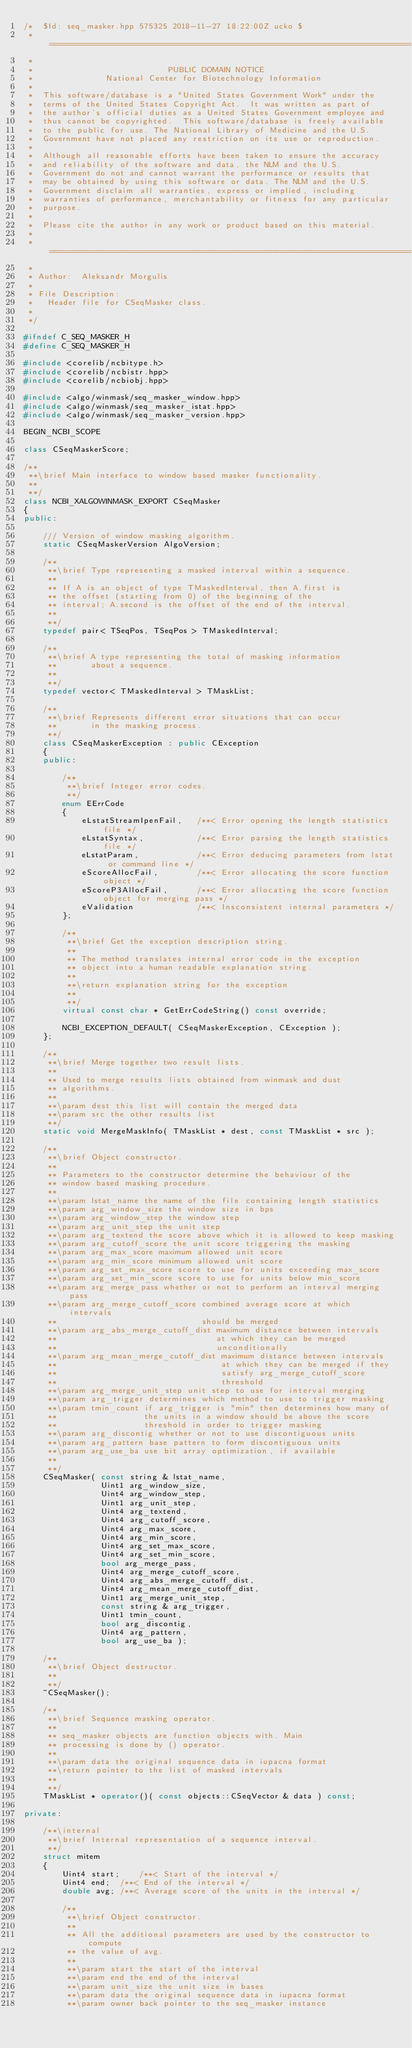<code> <loc_0><loc_0><loc_500><loc_500><_C++_>/*  $Id: seq_masker.hpp 575325 2018-11-27 18:22:00Z ucko $
 * ===========================================================================
 *
 *                            PUBLIC DOMAIN NOTICE
 *               National Center for Biotechnology Information
 *
 *  This software/database is a "United States Government Work" under the
 *  terms of the United States Copyright Act.  It was written as part of
 *  the author's official duties as a United States Government employee and
 *  thus cannot be copyrighted.  This software/database is freely available
 *  to the public for use. The National Library of Medicine and the U.S.
 *  Government have not placed any restriction on its use or reproduction.
 *
 *  Although all reasonable efforts have been taken to ensure the accuracy
 *  and reliability of the software and data, the NLM and the U.S.
 *  Government do not and cannot warrant the performance or results that
 *  may be obtained by using this software or data. The NLM and the U.S.
 *  Government disclaim all warranties, express or implied, including
 *  warranties of performance, merchantability or fitness for any particular
 *  purpose.
 *
 *  Please cite the author in any work or product based on this material.
 *
 * ===========================================================================
 *
 * Author:  Aleksandr Morgulis
 *
 * File Description:
 *   Header file for CSeqMasker class.
 *
 */

#ifndef C_SEQ_MASKER_H
#define C_SEQ_MASKER_H

#include <corelib/ncbitype.h>
#include <corelib/ncbistr.hpp>
#include <corelib/ncbiobj.hpp>

#include <algo/winmask/seq_masker_window.hpp>
#include <algo/winmask/seq_masker_istat.hpp>
#include <algo/winmask/seq_masker_version.hpp>

BEGIN_NCBI_SCOPE

class CSeqMaskerScore;

/**
 **\brief Main interface to window based masker functionality.
 **
 **/
class NCBI_XALGOWINMASK_EXPORT CSeqMasker
{
public:

    /// Version of window masking algorithm.
    static CSeqMaskerVersion AlgoVersion;

    /**
     **\brief Type representing a masked interval within a sequence.
     **
     ** If A is an object of type TMaskedInterval, then A.first is
     ** the offset (starting from 0) of the beginning of the
     ** interval; A.second is the offset of the end of the interval.
     **
     **/
    typedef pair< TSeqPos, TSeqPos > TMaskedInterval;

    /**
     **\brief A type representing the total of masking information 
     **       about a sequence.
     **
     **/
    typedef vector< TMaskedInterval > TMaskList;

    /**
     **\brief Represents different error situations that can occur
     **       in the masking process.
     **/
    class CSeqMaskerException : public CException
    {
    public:

        /**
         **\brief Integer error codes.
         **/
        enum EErrCode
        {
            eLstatStreamIpenFail,   /**< Error opening the length statistics file */
            eLstatSyntax,           /**< Error parsing the length statistics file */
            eLstatParam,            /**< Error deducing parameters from lstat or command line */
            eScoreAllocFail,        /**< Error allocating the score function object */
            eScoreP3AllocFail,      /**< Error allocating the score function object for merging pass */
            eValidation             /**< Insconsistent internal parameters */
        };

        /**
         **\brief Get the exception description string.
         **
         ** The method translates internal error code in the exception
         ** object into a human readable explanation string.
         **
         **\return explanation string for the exception
         **
         **/
        virtual const char * GetErrCodeString() const override;

        NCBI_EXCEPTION_DEFAULT( CSeqMaskerException, CException );
    };

    /**
     **\brief Merge together two result lists.
     **
     ** Used to merge results lists obtained from winmask and dust
     ** algorithms.
     **
     **\param dest this list will contain the merged data
     **\param src the other results list
     **/
    static void MergeMaskInfo( TMaskList * dest, const TMaskList * src );

    /**
     **\brief Object constructor.
     **
     ** Parameters to the constructor determine the behaviour of the
     ** window based masking procedure.
     **
     **\param lstat_name the name of the file containing length statistics
     **\param arg_window_size the window size in bps
     **\param arg_window_step the window step
     **\param arg_unit_step the unit step
     **\param arg_textend the score above which it is allowed to keep masking
     **\param arg_cutoff_score the unit score triggering the masking
     **\param arg_max_score maximum allowed unit score
     **\param arg_min_score minimum allowed unit score
     **\param arg_set_max_score score to use for units exceeding max_score
     **\param arg_set_min_score score to use for units below min_score
     **\param arg_merge_pass whether or not to perform an interval merging pass
     **\param arg_merge_cutoff_score combined average score at which intervals
     **                              should be merged
     **\param arg_abs_merge_cutoff_dist maximum distance between intervals
     **                                 at which they can be merged 
     **                                 unconditionally
     **\param arg_mean_merge_cutoff_dist maximum distance between intervals
     **                                  at which they can be merged if they
     **                                  satisfy arg_merge_cutoff_score 
     **                                  threshold
     **\param arg_merge_unit_step unit step to use for interval merging
     **\param arg_trigger determines which method to use to trigger masking
     **\param tmin_count if arg_trigger is "min" then determines how many of
     **                  the units in a window should be above the score
     **                  threshold in order to trigger masking
     **\param arg_discontig whether or not to use discontiguous units
     **\param arg_pattern base pattern to form discontiguous units
     **\param arg_use_ba use bit array optimization, if available
     **
     **/
    CSeqMasker( const string & lstat_name,
                Uint1 arg_window_size,
                Uint4 arg_window_step,
                Uint1 arg_unit_step,
                Uint4 arg_textend,
                Uint4 arg_cutoff_score,
                Uint4 arg_max_score,
                Uint4 arg_min_score,
                Uint4 arg_set_max_score,
                Uint4 arg_set_min_score,
                bool arg_merge_pass,
                Uint4 arg_merge_cutoff_score,
                Uint4 arg_abs_merge_cutoff_dist,
                Uint4 arg_mean_merge_cutoff_dist,
                Uint1 arg_merge_unit_step,
                const string & arg_trigger,
                Uint1 tmin_count,
                bool arg_discontig,
                Uint4 arg_pattern,
                bool arg_use_ba );

    /**
     **\brief Object destructor.
     **
     **/
    ~CSeqMasker(); 

    /**
     **\brief Sequence masking operator.
     **
     ** seq_masker objects are function objects with. Main
     ** processing is done by () operator.
     **
     **\param data the original sequence data in iupacna format
     **\return pointer to the list of masked intervals
     **
     **/
    TMaskList * operator()( const objects::CSeqVector & data ) const;

private:

    /**\internal
     **\brief Internal representation of a sequence interval.
     **/
    struct mitem
    {
        Uint4 start;    /**< Start of the interval */
        Uint4 end;  /**< End of the interval */
        double avg; /**< Average score of the units in the interval */

        /**
         **\brief Object constructor.
         **
         ** All the additional parameters are used by the constructor to compute
         ** the value of avg.
         **
         **\param start the start of the interval
         **\param end the end of the interval
         **\param unit_size the unit size in bases
         **\param data the original sequence data in iupacna format
         **\param owner back pointer to the seq_masker instance</code> 